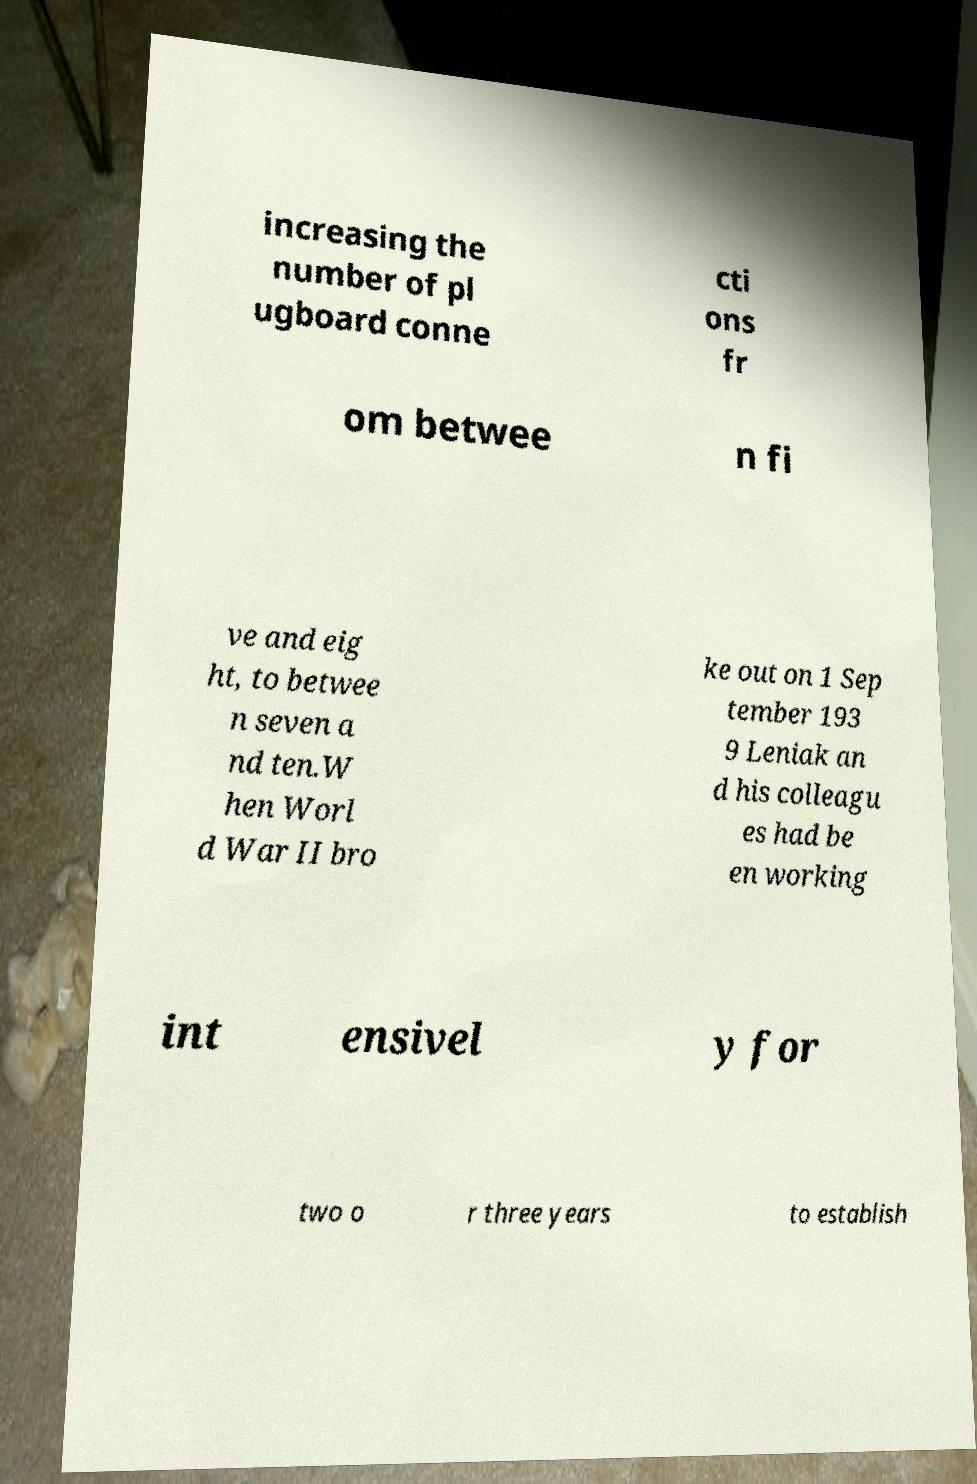What messages or text are displayed in this image? I need them in a readable, typed format. increasing the number of pl ugboard conne cti ons fr om betwee n fi ve and eig ht, to betwee n seven a nd ten.W hen Worl d War II bro ke out on 1 Sep tember 193 9 Leniak an d his colleagu es had be en working int ensivel y for two o r three years to establish 